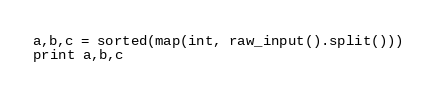<code> <loc_0><loc_0><loc_500><loc_500><_Python_>a,b,c = sorted(map(int, raw_input().split()))
print a,b,c</code> 